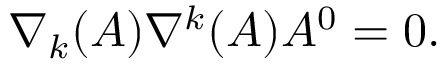<formula> <loc_0><loc_0><loc_500><loc_500>\nabla _ { k } ( A ) \nabla ^ { k } ( A ) A ^ { 0 } = 0 .</formula> 